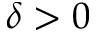Convert formula to latex. <formula><loc_0><loc_0><loc_500><loc_500>\delta > 0</formula> 